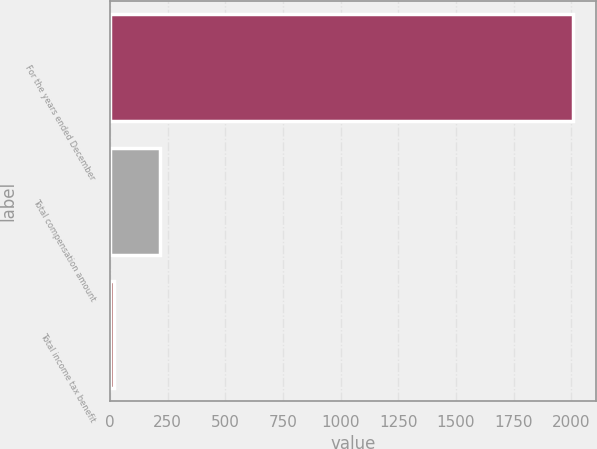Convert chart to OTSL. <chart><loc_0><loc_0><loc_500><loc_500><bar_chart><fcel>For the years ended December<fcel>Total compensation amount<fcel>Total income tax benefit<nl><fcel>2009<fcel>218.09<fcel>19.1<nl></chart> 